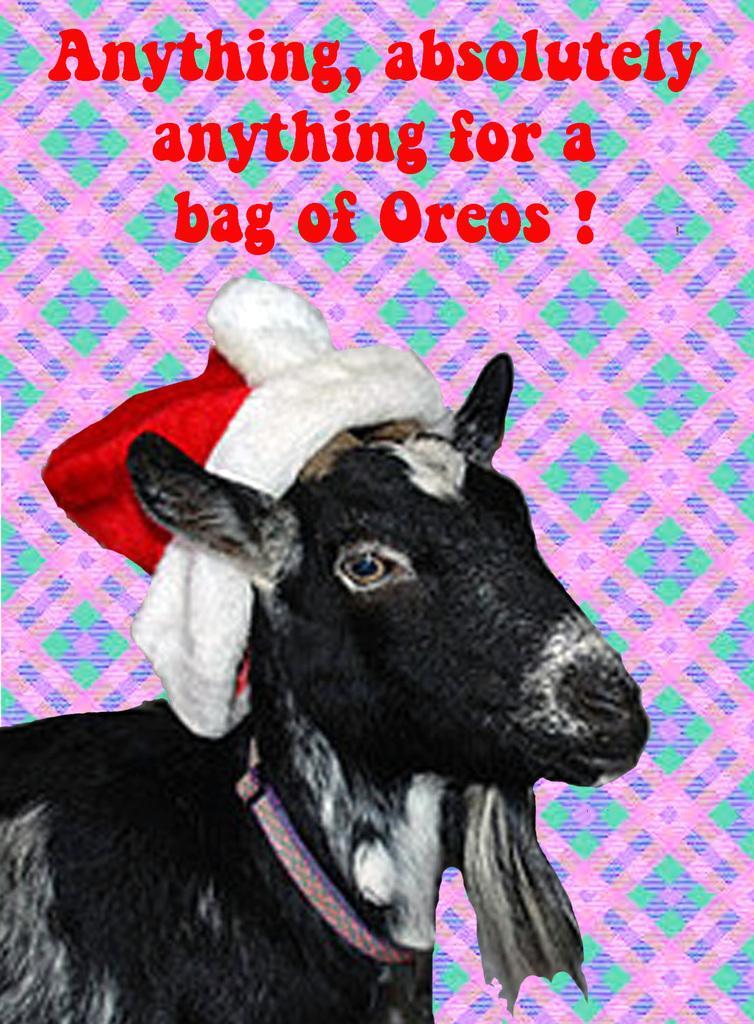Please provide a concise description of this image. In the picture I can see a goat and there is a Christmas cap on the head. I can see the text at the top of the picture. 